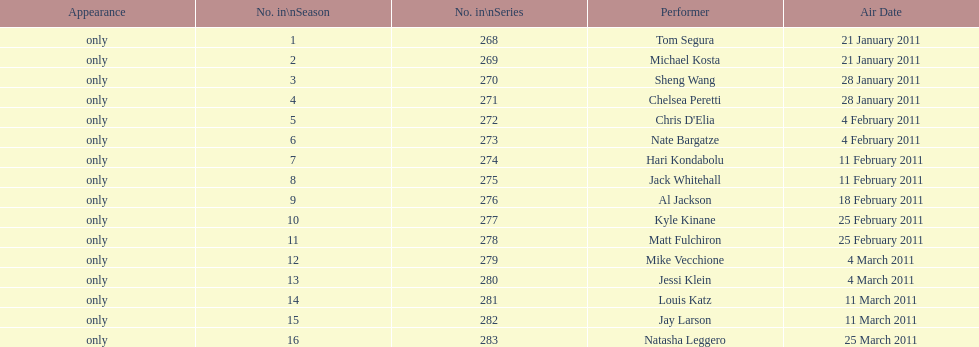Who appeared first tom segura or jay larson? Tom Segura. 